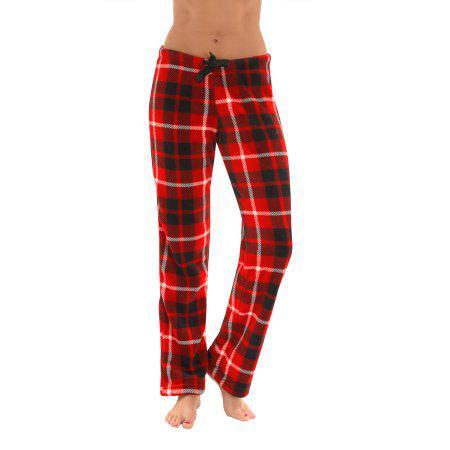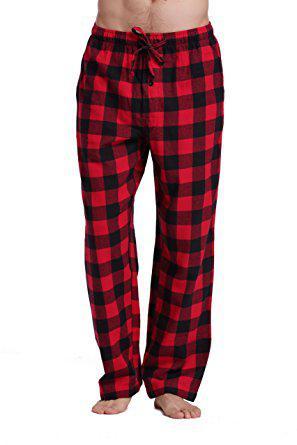The first image is the image on the left, the second image is the image on the right. Given the left and right images, does the statement "one pair of pants is worn by a human and the other is by itself." hold true? Answer yes or no. No. 